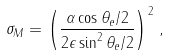<formula> <loc_0><loc_0><loc_500><loc_500>\sigma _ { M } = \left ( \frac { \alpha \cos \theta _ { e } / 2 } { 2 \epsilon \sin ^ { 2 } \theta _ { e } / 2 } \right ) ^ { 2 } \, ,</formula> 